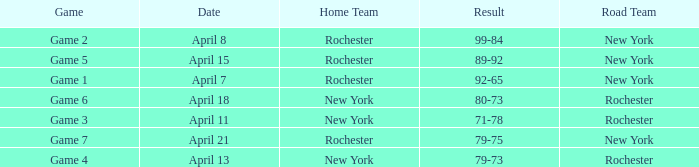Which Date has a Game of game 3? April 11. 